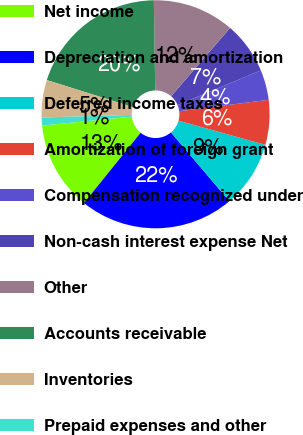<chart> <loc_0><loc_0><loc_500><loc_500><pie_chart><fcel>Net income<fcel>Depreciation and amortization<fcel>Deferred income taxes<fcel>Amortization of foreign grant<fcel>Compensation recognized under<fcel>Non-cash interest expense Net<fcel>Other<fcel>Accounts receivable<fcel>Inventories<fcel>Prepaid expenses and other<nl><fcel>12.61%<fcel>22.01%<fcel>9.48%<fcel>6.35%<fcel>4.26%<fcel>7.39%<fcel>11.57%<fcel>19.92%<fcel>5.3%<fcel>1.13%<nl></chart> 